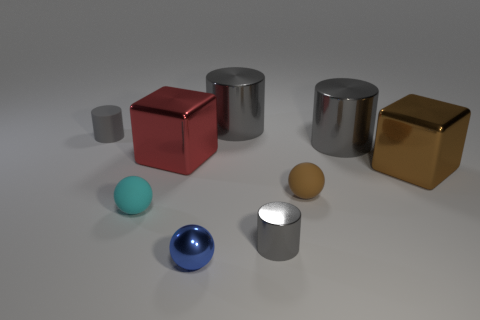Add 1 large gray blocks. How many objects exist? 10 Subtract all cylinders. How many objects are left? 5 Subtract all small metallic balls. Subtract all tiny blue spheres. How many objects are left? 7 Add 1 gray things. How many gray things are left? 5 Add 2 rubber spheres. How many rubber spheres exist? 4 Subtract 1 cyan balls. How many objects are left? 8 